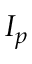Convert formula to latex. <formula><loc_0><loc_0><loc_500><loc_500>I _ { p }</formula> 